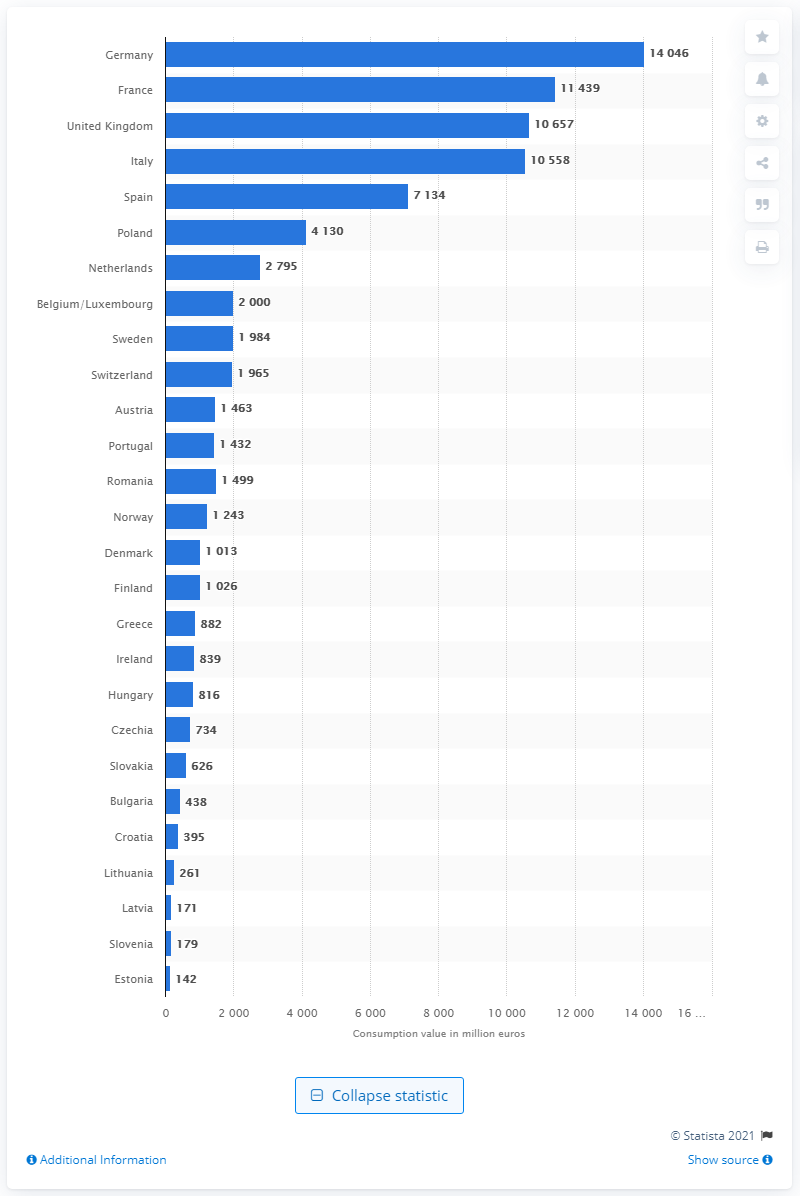Give some essential details in this illustration. The value of cosmetics in Germany in 2019 was 14,046. Cosmetics had a value of 10,657 million pounds in the United Kingdom in 2019. 